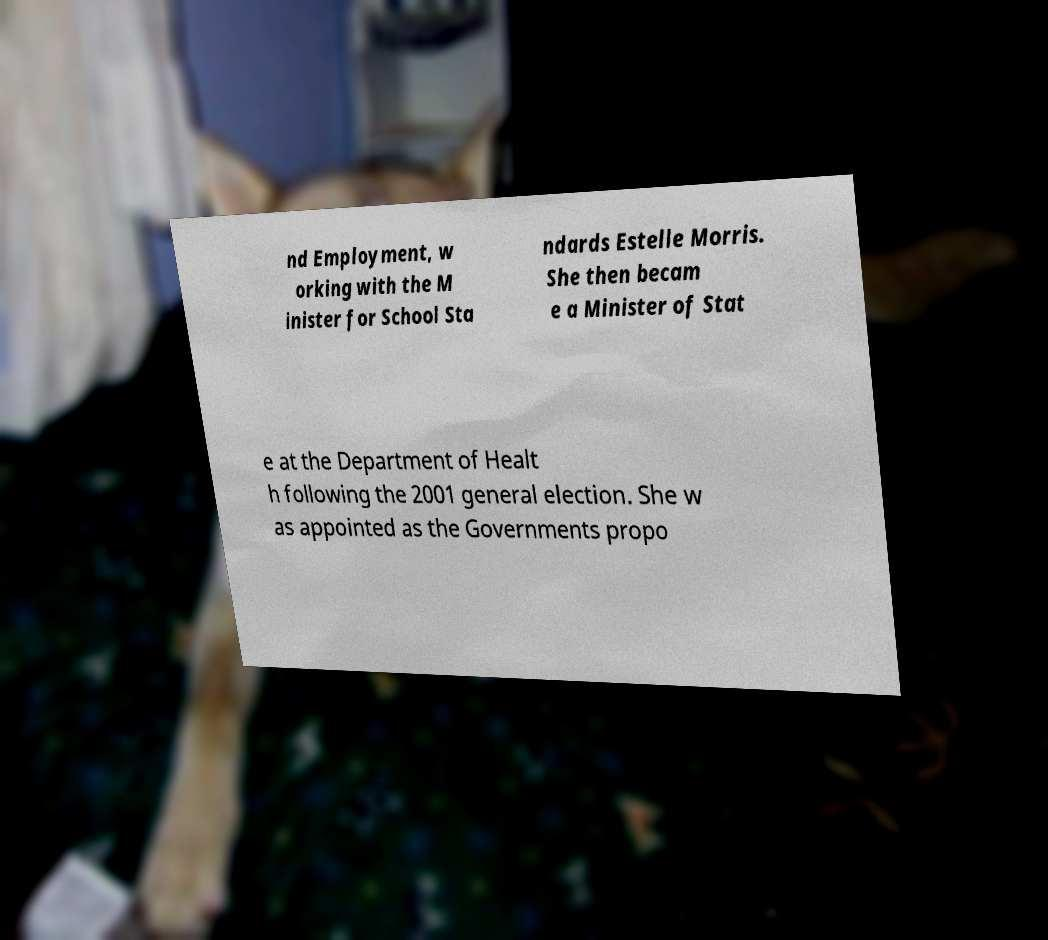I need the written content from this picture converted into text. Can you do that? nd Employment, w orking with the M inister for School Sta ndards Estelle Morris. She then becam e a Minister of Stat e at the Department of Healt h following the 2001 general election. She w as appointed as the Governments propo 